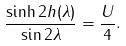Convert formula to latex. <formula><loc_0><loc_0><loc_500><loc_500>\frac { \sinh 2 h ( \lambda ) } { \sin 2 \lambda } = \frac { U } { 4 } .</formula> 